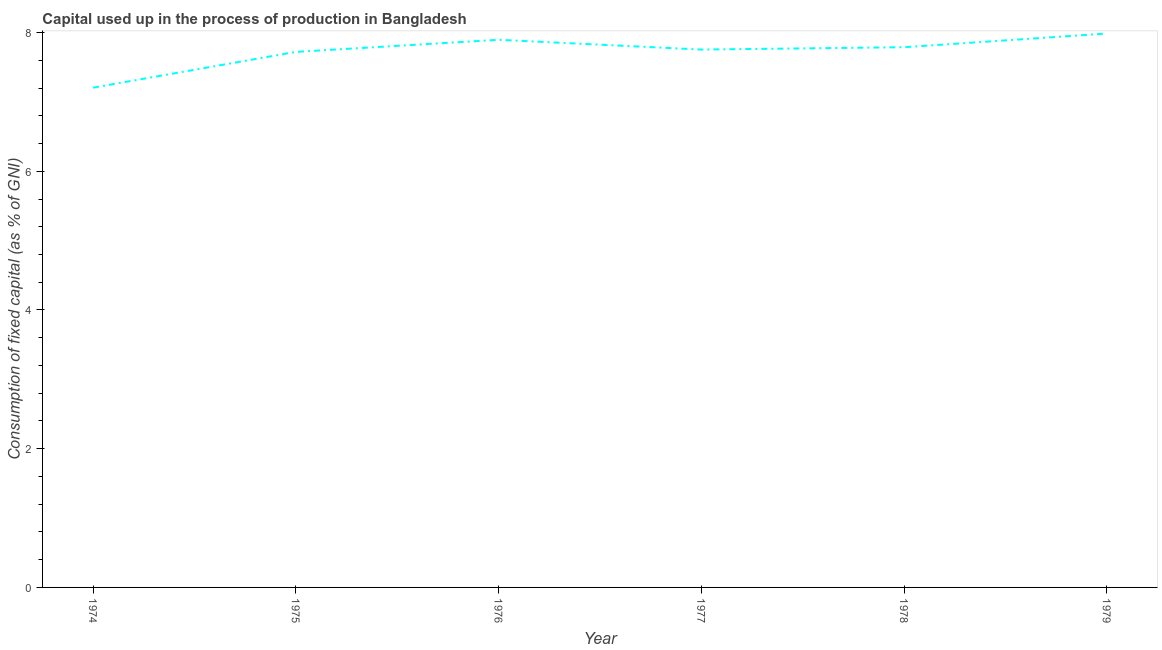What is the consumption of fixed capital in 1978?
Your response must be concise. 7.79. Across all years, what is the maximum consumption of fixed capital?
Offer a terse response. 7.99. Across all years, what is the minimum consumption of fixed capital?
Your answer should be compact. 7.21. In which year was the consumption of fixed capital maximum?
Your answer should be very brief. 1979. In which year was the consumption of fixed capital minimum?
Offer a terse response. 1974. What is the sum of the consumption of fixed capital?
Provide a short and direct response. 46.35. What is the difference between the consumption of fixed capital in 1976 and 1979?
Your response must be concise. -0.09. What is the average consumption of fixed capital per year?
Your response must be concise. 7.73. What is the median consumption of fixed capital?
Your response must be concise. 7.77. Do a majority of the years between 1975 and 1978 (inclusive) have consumption of fixed capital greater than 0.4 %?
Your response must be concise. Yes. What is the ratio of the consumption of fixed capital in 1977 to that in 1978?
Offer a very short reply. 1. What is the difference between the highest and the second highest consumption of fixed capital?
Offer a very short reply. 0.09. What is the difference between the highest and the lowest consumption of fixed capital?
Your answer should be compact. 0.78. Does the consumption of fixed capital monotonically increase over the years?
Make the answer very short. No. Are the values on the major ticks of Y-axis written in scientific E-notation?
Your answer should be very brief. No. Does the graph contain any zero values?
Provide a succinct answer. No. What is the title of the graph?
Give a very brief answer. Capital used up in the process of production in Bangladesh. What is the label or title of the X-axis?
Ensure brevity in your answer.  Year. What is the label or title of the Y-axis?
Your answer should be compact. Consumption of fixed capital (as % of GNI). What is the Consumption of fixed capital (as % of GNI) in 1974?
Give a very brief answer. 7.21. What is the Consumption of fixed capital (as % of GNI) in 1975?
Offer a very short reply. 7.72. What is the Consumption of fixed capital (as % of GNI) of 1976?
Give a very brief answer. 7.9. What is the Consumption of fixed capital (as % of GNI) of 1977?
Your answer should be compact. 7.75. What is the Consumption of fixed capital (as % of GNI) in 1978?
Your answer should be compact. 7.79. What is the Consumption of fixed capital (as % of GNI) of 1979?
Provide a short and direct response. 7.99. What is the difference between the Consumption of fixed capital (as % of GNI) in 1974 and 1975?
Your answer should be compact. -0.52. What is the difference between the Consumption of fixed capital (as % of GNI) in 1974 and 1976?
Ensure brevity in your answer.  -0.69. What is the difference between the Consumption of fixed capital (as % of GNI) in 1974 and 1977?
Keep it short and to the point. -0.55. What is the difference between the Consumption of fixed capital (as % of GNI) in 1974 and 1978?
Your answer should be very brief. -0.58. What is the difference between the Consumption of fixed capital (as % of GNI) in 1974 and 1979?
Ensure brevity in your answer.  -0.78. What is the difference between the Consumption of fixed capital (as % of GNI) in 1975 and 1976?
Keep it short and to the point. -0.17. What is the difference between the Consumption of fixed capital (as % of GNI) in 1975 and 1977?
Provide a succinct answer. -0.03. What is the difference between the Consumption of fixed capital (as % of GNI) in 1975 and 1978?
Keep it short and to the point. -0.07. What is the difference between the Consumption of fixed capital (as % of GNI) in 1975 and 1979?
Your answer should be compact. -0.26. What is the difference between the Consumption of fixed capital (as % of GNI) in 1976 and 1977?
Your response must be concise. 0.14. What is the difference between the Consumption of fixed capital (as % of GNI) in 1976 and 1978?
Provide a succinct answer. 0.11. What is the difference between the Consumption of fixed capital (as % of GNI) in 1976 and 1979?
Offer a terse response. -0.09. What is the difference between the Consumption of fixed capital (as % of GNI) in 1977 and 1978?
Give a very brief answer. -0.03. What is the difference between the Consumption of fixed capital (as % of GNI) in 1977 and 1979?
Keep it short and to the point. -0.23. What is the difference between the Consumption of fixed capital (as % of GNI) in 1978 and 1979?
Your response must be concise. -0.2. What is the ratio of the Consumption of fixed capital (as % of GNI) in 1974 to that in 1975?
Provide a short and direct response. 0.93. What is the ratio of the Consumption of fixed capital (as % of GNI) in 1974 to that in 1977?
Provide a short and direct response. 0.93. What is the ratio of the Consumption of fixed capital (as % of GNI) in 1974 to that in 1978?
Provide a succinct answer. 0.93. What is the ratio of the Consumption of fixed capital (as % of GNI) in 1974 to that in 1979?
Give a very brief answer. 0.9. What is the ratio of the Consumption of fixed capital (as % of GNI) in 1975 to that in 1976?
Make the answer very short. 0.98. What is the ratio of the Consumption of fixed capital (as % of GNI) in 1975 to that in 1979?
Your answer should be very brief. 0.97. What is the ratio of the Consumption of fixed capital (as % of GNI) in 1976 to that in 1977?
Your answer should be very brief. 1.02. What is the ratio of the Consumption of fixed capital (as % of GNI) in 1976 to that in 1978?
Offer a terse response. 1.01. What is the ratio of the Consumption of fixed capital (as % of GNI) in 1977 to that in 1979?
Offer a terse response. 0.97. 